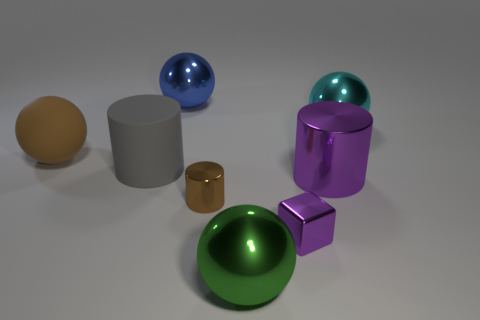How many other things are there of the same size as the blue metal object?
Provide a succinct answer. 5. Do the brown thing in front of the brown matte ball and the blue thing have the same material?
Keep it short and to the point. Yes. What is the shape of the small metal thing right of the shiny sphere in front of the tiny thing that is in front of the tiny brown cylinder?
Give a very brief answer. Cube. Are there the same number of objects that are in front of the small metallic block and big balls that are in front of the big purple object?
Your response must be concise. Yes. What is the color of the metal block that is the same size as the brown metallic cylinder?
Your answer should be compact. Purple. How many small objects are blue rubber things or purple things?
Your answer should be very brief. 1. What material is the cylinder that is behind the brown shiny cylinder and right of the blue shiny ball?
Provide a succinct answer. Metal. Do the tiny metallic thing that is right of the green sphere and the big metal object left of the big green metallic thing have the same shape?
Your response must be concise. No. The object that is the same color as the tiny cube is what shape?
Your response must be concise. Cylinder. What number of things are large metallic balls in front of the blue thing or large rubber cylinders?
Your answer should be very brief. 3. 